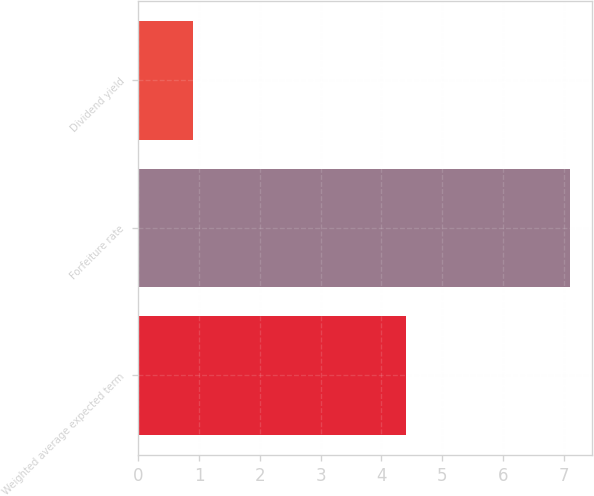Convert chart to OTSL. <chart><loc_0><loc_0><loc_500><loc_500><bar_chart><fcel>Weighted average expected term<fcel>Forfeiture rate<fcel>Dividend yield<nl><fcel>4.4<fcel>7.1<fcel>0.9<nl></chart> 